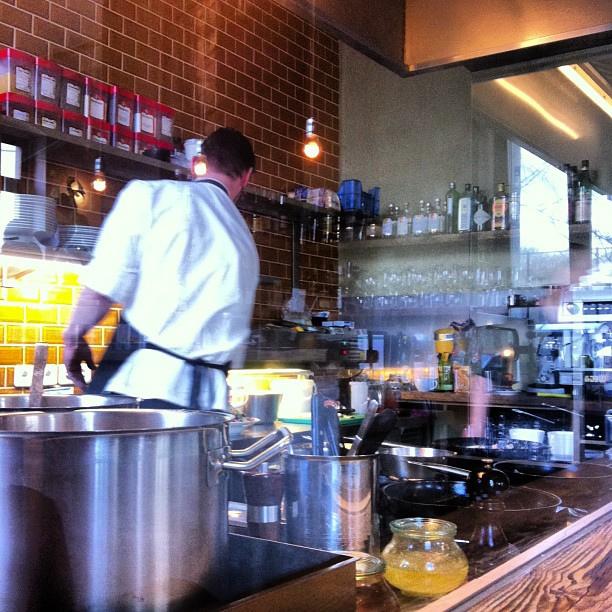Is the man wearing an apron?
Short answer required. Yes. What is the man doing?
Concise answer only. Cooking. Where are the spices?
Short answer required. Top shelf. 